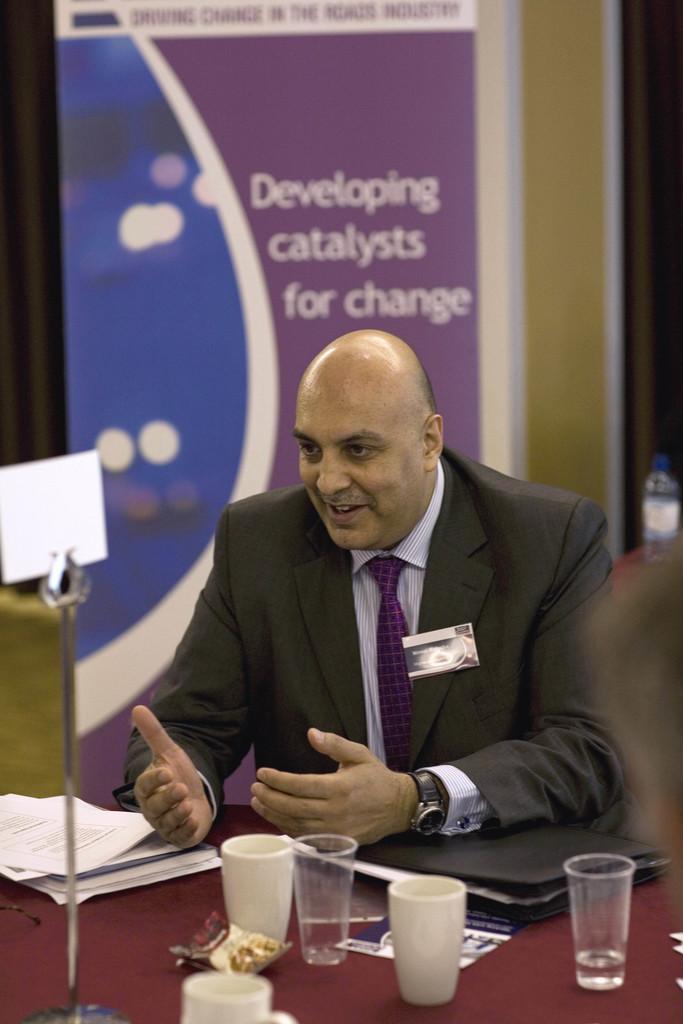Can you describe this image briefly? This picture shows a man seated on the chair and speaking and we see few glasses and a cup on the table. 